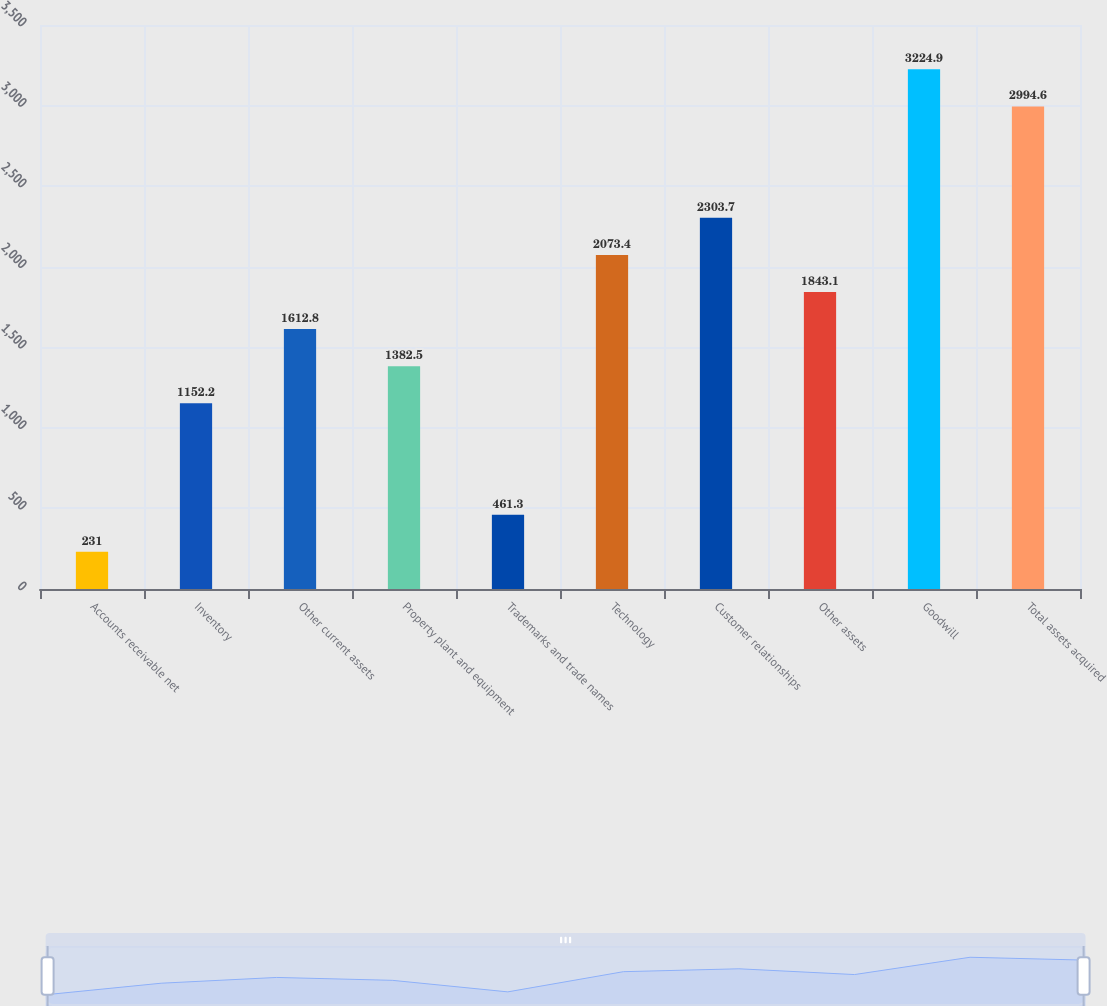Convert chart to OTSL. <chart><loc_0><loc_0><loc_500><loc_500><bar_chart><fcel>Accounts receivable net<fcel>Inventory<fcel>Other current assets<fcel>Property plant and equipment<fcel>Trademarks and trade names<fcel>Technology<fcel>Customer relationships<fcel>Other assets<fcel>Goodwill<fcel>Total assets acquired<nl><fcel>231<fcel>1152.2<fcel>1612.8<fcel>1382.5<fcel>461.3<fcel>2073.4<fcel>2303.7<fcel>1843.1<fcel>3224.9<fcel>2994.6<nl></chart> 